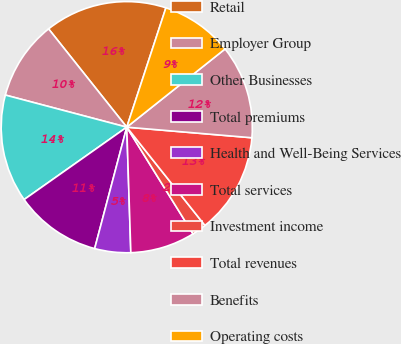Convert chart to OTSL. <chart><loc_0><loc_0><loc_500><loc_500><pie_chart><fcel>Retail<fcel>Employer Group<fcel>Other Businesses<fcel>Total premiums<fcel>Health and Well-Being Services<fcel>Total services<fcel>Investment income<fcel>Total revenues<fcel>Benefits<fcel>Operating costs<nl><fcel>15.74%<fcel>10.19%<fcel>13.89%<fcel>11.11%<fcel>4.63%<fcel>8.33%<fcel>1.85%<fcel>12.96%<fcel>12.04%<fcel>9.26%<nl></chart> 